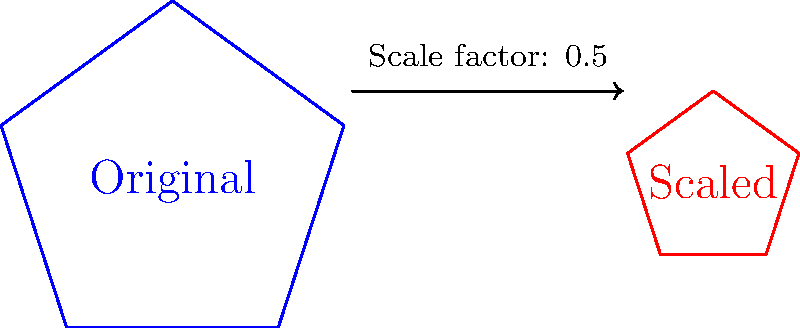As an artist working on a project about neighborhood change, you need to create a scaled-down version of a local map to fit within a smaller canvas. If the original map measures 20 inches across its widest point and you want to reduce it to fit within a 10-inch wide canvas, what scale factor should you use? How would this scaling affect the area of the map representation? To solve this problem, let's follow these steps:

1. Determine the scale factor:
   - Original width: 20 inches
   - Desired width: 10 inches
   - Scale factor = Desired width / Original width
   - Scale factor = $\frac{10}{20} = 0.5$ or $\frac{1}{2}$

2. Effect on area:
   - When we scale a two-dimensional figure, the area is affected by the square of the scale factor.
   - Area scale factor = (Linear scale factor)$^2$
   - Area scale factor = $0.5^2 = 0.25$ or $\frac{1}{4}$

3. Interpretation:
   - The linear dimensions (length and width) will be reduced to half (0.5) of their original size.
   - The area of the scaled map will be one-quarter (0.25) of the original map's area.

This scaling demonstrates how gentrification can sometimes be visualized through changing representations of neighborhoods, where the "shrinking" of a community's space on maps might reflect real-world pressures and displacements.
Answer: Scale factor: 0.5; Area reduced to 0.25 of original 